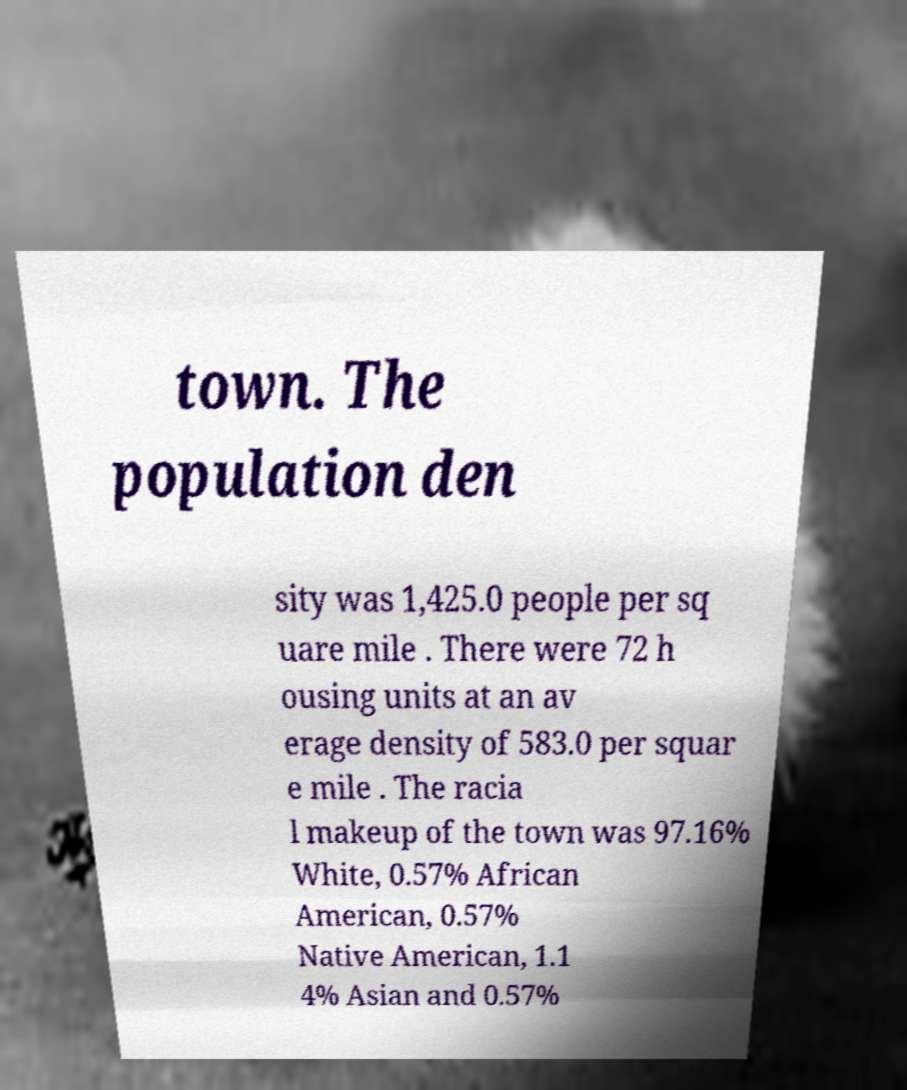There's text embedded in this image that I need extracted. Can you transcribe it verbatim? town. The population den sity was 1,425.0 people per sq uare mile . There were 72 h ousing units at an av erage density of 583.0 per squar e mile . The racia l makeup of the town was 97.16% White, 0.57% African American, 0.57% Native American, 1.1 4% Asian and 0.57% 